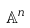Convert formula to latex. <formula><loc_0><loc_0><loc_500><loc_500>\mathbb { A } ^ { n }</formula> 